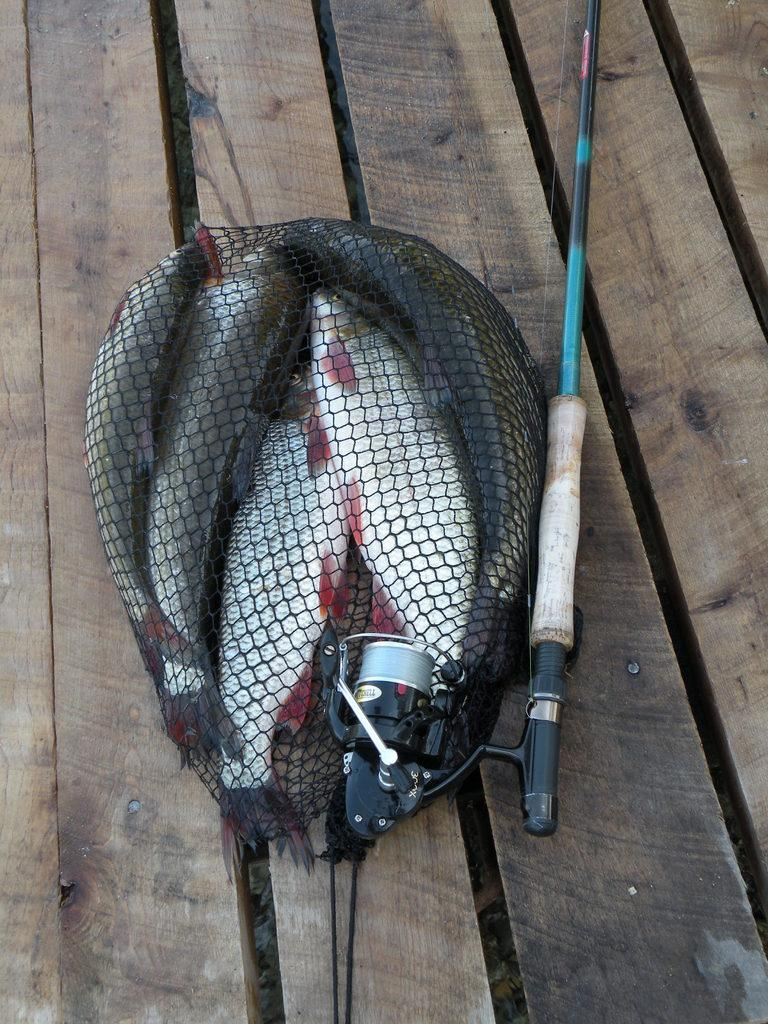What is the main object in the center of the image? There is a fishing rod in the center of the image. What can be seen near the fishing rod? There are fishes in a net in the image. What type of environment is depicted in the background of the image? There is a wood in the background of the image. What type of wrench is being used to catch the fishes in the image? There is no wrench present in the image; the fishing rod is being used to catch the fishes. How does the image depict the fishes stopping their movement? The image does not show the fishes stopping their movement; they are already in a net. 